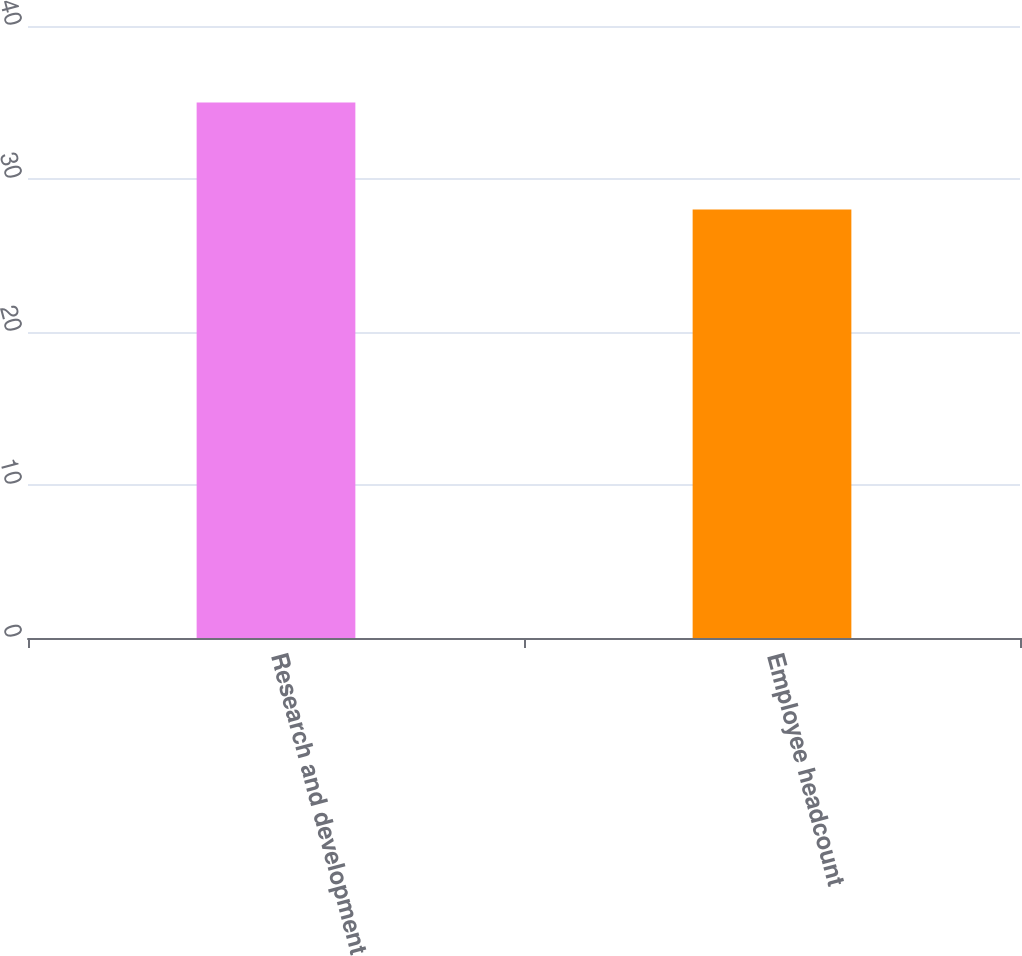<chart> <loc_0><loc_0><loc_500><loc_500><bar_chart><fcel>Research and development<fcel>Employee headcount<nl><fcel>35<fcel>28<nl></chart> 